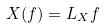<formula> <loc_0><loc_0><loc_500><loc_500>X ( f ) = L _ { X } f</formula> 